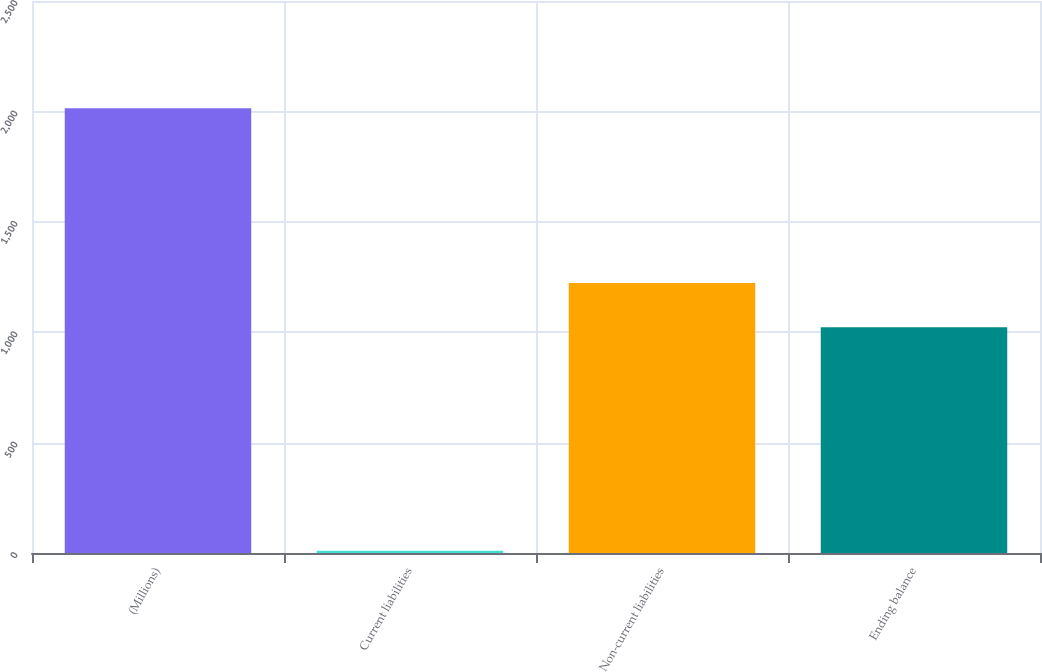<chart> <loc_0><loc_0><loc_500><loc_500><bar_chart><fcel>(Millions)<fcel>Current liabilities<fcel>Non-current liabilities<fcel>Ending balance<nl><fcel>2014<fcel>10<fcel>1222.4<fcel>1022<nl></chart> 